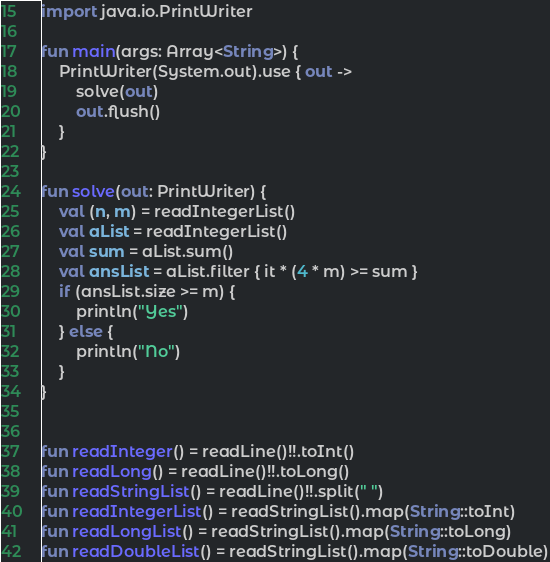Convert code to text. <code><loc_0><loc_0><loc_500><loc_500><_Kotlin_>import java.io.PrintWriter

fun main(args: Array<String>) {
    PrintWriter(System.out).use { out ->
        solve(out)
        out.flush()
    }
}

fun solve(out: PrintWriter) {
    val (n, m) = readIntegerList()
    val aList = readIntegerList()
    val sum = aList.sum()
    val ansList = aList.filter { it * (4 * m) >= sum }
    if (ansList.size >= m) {
        println("Yes")
    } else {
        println("No")
    }
}


fun readInteger() = readLine()!!.toInt()
fun readLong() = readLine()!!.toLong()
fun readStringList() = readLine()!!.split(" ")
fun readIntegerList() = readStringList().map(String::toInt)
fun readLongList() = readStringList().map(String::toLong)
fun readDoubleList() = readStringList().map(String::toDouble)
</code> 